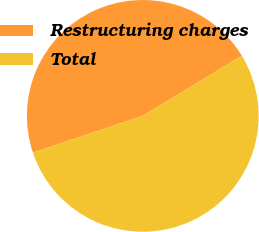Convert chart to OTSL. <chart><loc_0><loc_0><loc_500><loc_500><pie_chart><fcel>Restructuring charges<fcel>Total<nl><fcel>46.44%<fcel>53.56%<nl></chart> 